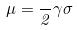Convert formula to latex. <formula><loc_0><loc_0><loc_500><loc_500>\mu = \frac { } { 2 } \gamma \sigma</formula> 